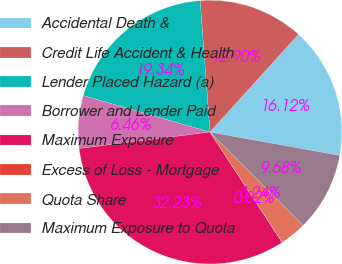Convert chart. <chart><loc_0><loc_0><loc_500><loc_500><pie_chart><fcel>Accidental Death &<fcel>Credit Life Accident & Health<fcel>Lender Placed Hazard (a)<fcel>Borrower and Lender Paid<fcel>Maximum Exposure<fcel>Excess of Loss - Mortgage<fcel>Quota Share<fcel>Maximum Exposure to Quota<nl><fcel>16.12%<fcel>12.9%<fcel>19.34%<fcel>6.46%<fcel>32.23%<fcel>0.02%<fcel>3.24%<fcel>9.68%<nl></chart> 